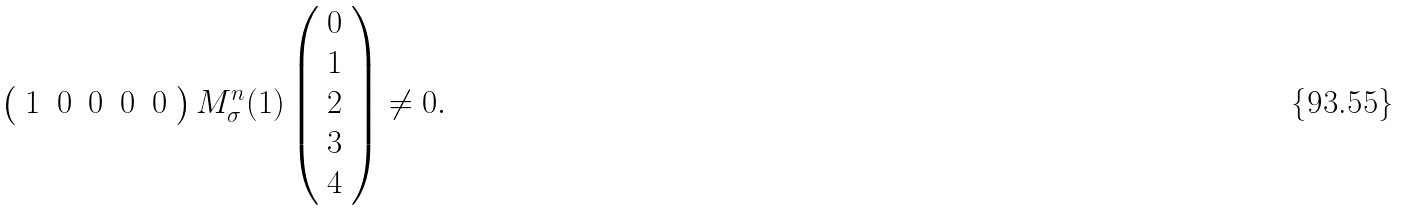<formula> <loc_0><loc_0><loc_500><loc_500>\left ( \begin{array} { c c c c c } 1 & 0 & 0 & 0 & 0 \end{array} \right ) M _ { \sigma } ^ { n } ( 1 ) \left ( \begin{array} { c } 0 \\ 1 \\ 2 \\ 3 \\ 4 \end{array} \right ) \neq 0 .</formula> 